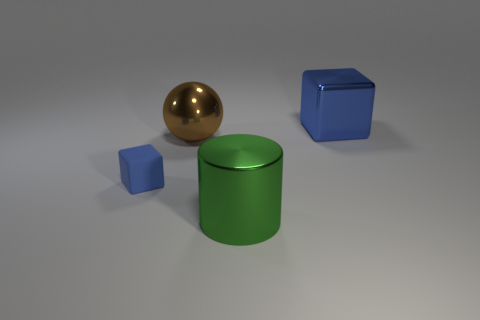Add 2 purple metallic cubes. How many objects exist? 6 Subtract 0 cyan cylinders. How many objects are left? 4 Subtract all cylinders. How many objects are left? 3 Subtract all brown blocks. Subtract all purple spheres. How many blocks are left? 2 Subtract all tiny yellow shiny things. Subtract all big green metal things. How many objects are left? 3 Add 4 tiny things. How many tiny things are left? 5 Add 4 large metal balls. How many large metal balls exist? 5 